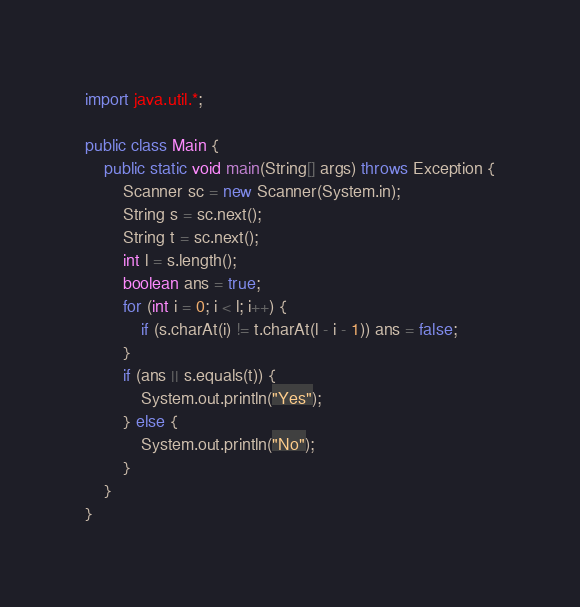<code> <loc_0><loc_0><loc_500><loc_500><_Java_>import java.util.*;

public class Main {
    public static void main(String[] args) throws Exception {
        Scanner sc = new Scanner(System.in);
        String s = sc.next();
        String t = sc.next();
        int l = s.length();
        boolean ans = true;
        for (int i = 0; i < l; i++) {
            if (s.charAt(i) != t.charAt(l - i - 1)) ans = false;
        }
        if (ans || s.equals(t)) {
            System.out.println("Yes");
        } else {
            System.out.println("No");
        }
    }    
}
</code> 